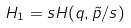Convert formula to latex. <formula><loc_0><loc_0><loc_500><loc_500>H _ { 1 } = s H ( q , \tilde { p } / s )</formula> 